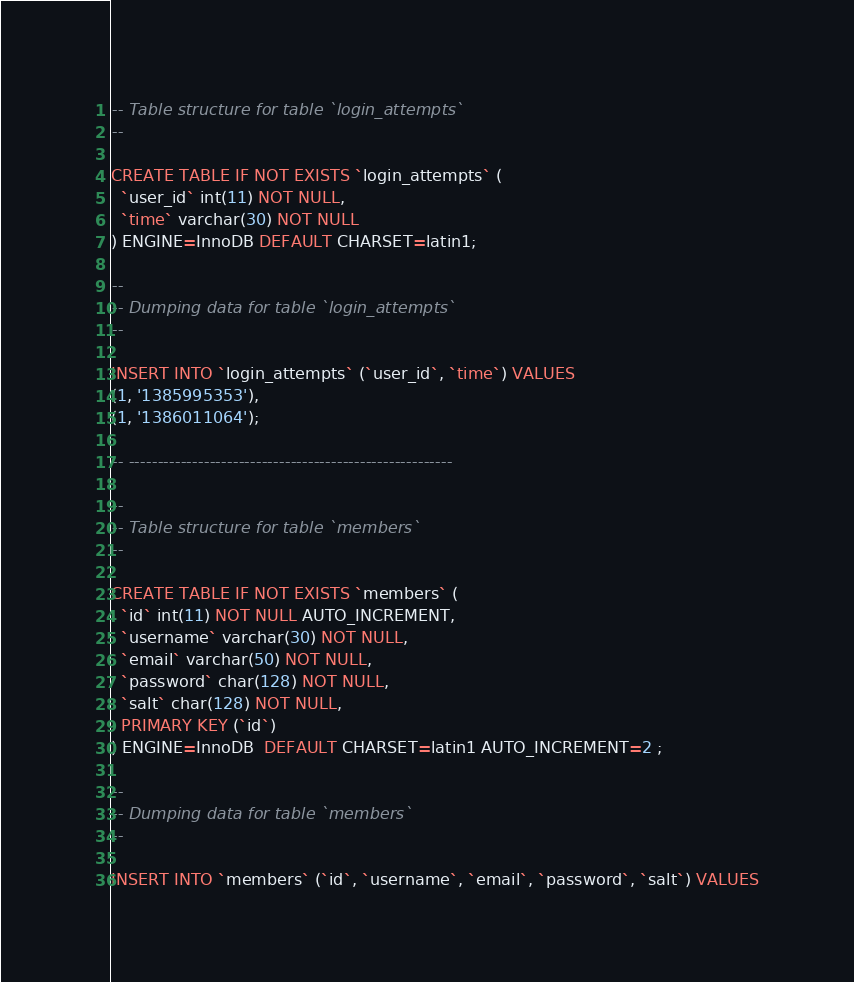Convert code to text. <code><loc_0><loc_0><loc_500><loc_500><_SQL_>-- Table structure for table `login_attempts`
--

CREATE TABLE IF NOT EXISTS `login_attempts` (
  `user_id` int(11) NOT NULL,
  `time` varchar(30) NOT NULL
) ENGINE=InnoDB DEFAULT CHARSET=latin1;

--
-- Dumping data for table `login_attempts`
--

INSERT INTO `login_attempts` (`user_id`, `time`) VALUES
(1, '1385995353'),
(1, '1386011064');

-- --------------------------------------------------------

--
-- Table structure for table `members`
--

CREATE TABLE IF NOT EXISTS `members` (
  `id` int(11) NOT NULL AUTO_INCREMENT,
  `username` varchar(30) NOT NULL,
  `email` varchar(50) NOT NULL,
  `password` char(128) NOT NULL,
  `salt` char(128) NOT NULL,
  PRIMARY KEY (`id`)
) ENGINE=InnoDB  DEFAULT CHARSET=latin1 AUTO_INCREMENT=2 ;

--
-- Dumping data for table `members`
--

INSERT INTO `members` (`id`, `username`, `email`, `password`, `salt`) VALUES</code> 